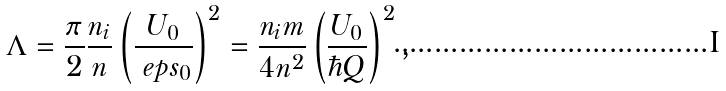<formula> <loc_0><loc_0><loc_500><loc_500>\Lambda = \frac { \pi } { 2 } \frac { n _ { i } } { n } \left ( \frac { U _ { 0 } } { \ e p s _ { 0 } } \right ) ^ { 2 } = \frac { n _ { i } m } { 4 n ^ { 2 } } \left ( \frac { U _ { 0 } } { \hbar { Q } } \right ) ^ { 2 } ,</formula> 